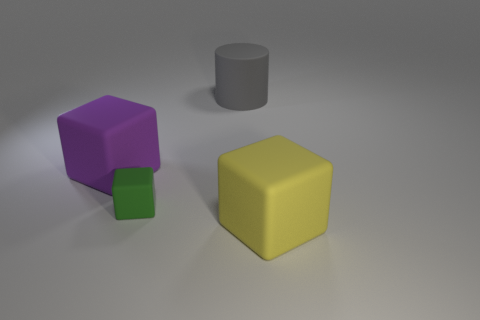There is a green object; is it the same size as the object to the right of the large cylinder?
Your answer should be very brief. No. Is the number of big purple rubber cubes greater than the number of matte blocks?
Offer a very short reply. No. Are the large block that is on the left side of the large yellow block and the big object that is on the right side of the gray cylinder made of the same material?
Make the answer very short. Yes. What material is the big gray cylinder?
Provide a succinct answer. Rubber. Are there more green objects that are in front of the yellow thing than red matte balls?
Provide a short and direct response. No. What number of big objects are on the right side of the big block that is behind the big rubber object in front of the large purple rubber cube?
Offer a terse response. 2. The block that is to the left of the gray cylinder and right of the purple matte cube is made of what material?
Give a very brief answer. Rubber. The small matte object is what color?
Offer a very short reply. Green. Is the number of rubber cubes to the right of the tiny object greater than the number of large purple matte objects that are behind the big gray matte object?
Keep it short and to the point. Yes. There is a large rubber block right of the large matte cylinder; what is its color?
Offer a terse response. Yellow. 